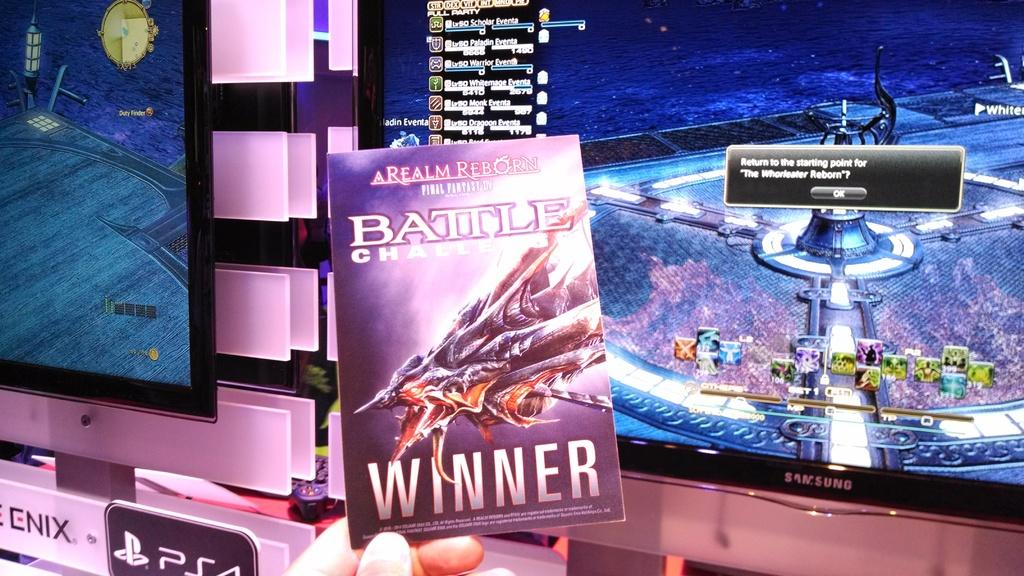<image>
Render a clear and concise summary of the photo. Samsung screens showing scifi games stand beind this science fiction book entitled A Realm Reborn. 